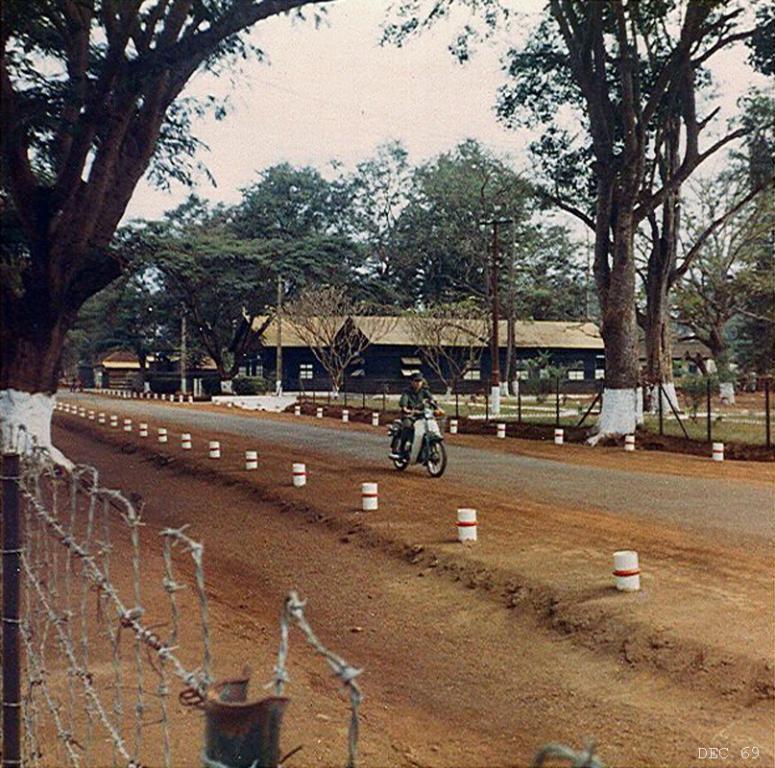Can you describe this image briefly? In this image we can see a person is riding a bike on the road. Here we can see poles, trees, sheds, ground, and fence. In the background there is sky. 